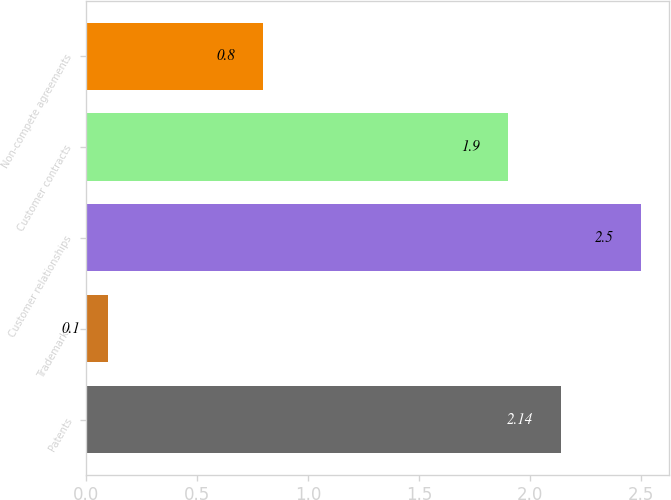<chart> <loc_0><loc_0><loc_500><loc_500><bar_chart><fcel>Patents<fcel>Trademarks<fcel>Customer relationships<fcel>Customer contracts<fcel>Non-compete agreements<nl><fcel>2.14<fcel>0.1<fcel>2.5<fcel>1.9<fcel>0.8<nl></chart> 